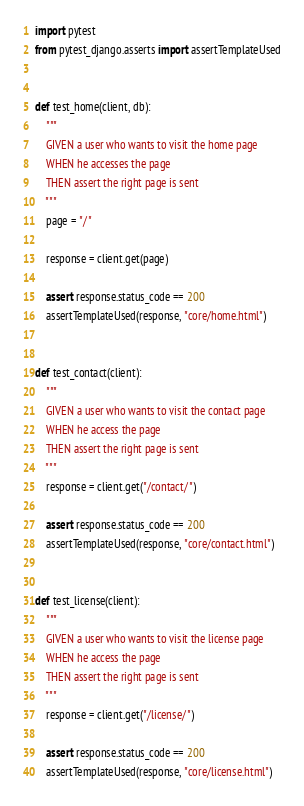Convert code to text. <code><loc_0><loc_0><loc_500><loc_500><_Python_>import pytest
from pytest_django.asserts import assertTemplateUsed


def test_home(client, db):
    """
	GIVEN a user who wants to visit the home page
	WHEN he accesses the page
	THEN assert the right page is sent
	"""
    page = "/"

    response = client.get(page)

    assert response.status_code == 200
    assertTemplateUsed(response, "core/home.html")


def test_contact(client):
    """
	GIVEN a user who wants to visit the contact page
	WHEN he access the page
	THEN assert the right page is sent
	"""
    response = client.get("/contact/")

    assert response.status_code == 200
    assertTemplateUsed(response, "core/contact.html")


def test_license(client):
    """
	GIVEN a user who wants to visit the license page
	WHEN he access the page
	THEN assert the right page is sent
	"""
    response = client.get("/license/")

    assert response.status_code == 200
    assertTemplateUsed(response, "core/license.html")
</code> 